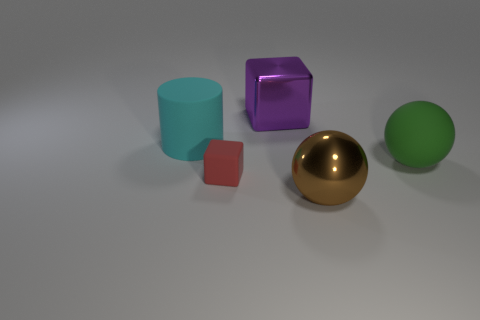Subtract all brown cylinders. Subtract all purple spheres. How many cylinders are left? 1 Add 1 large gray metal cylinders. How many objects exist? 6 Subtract all balls. How many objects are left? 3 Add 3 big cyan matte things. How many big cyan matte things are left? 4 Add 5 tiny cyan things. How many tiny cyan things exist? 5 Subtract 0 gray blocks. How many objects are left? 5 Subtract all brown metallic spheres. Subtract all purple shiny blocks. How many objects are left? 3 